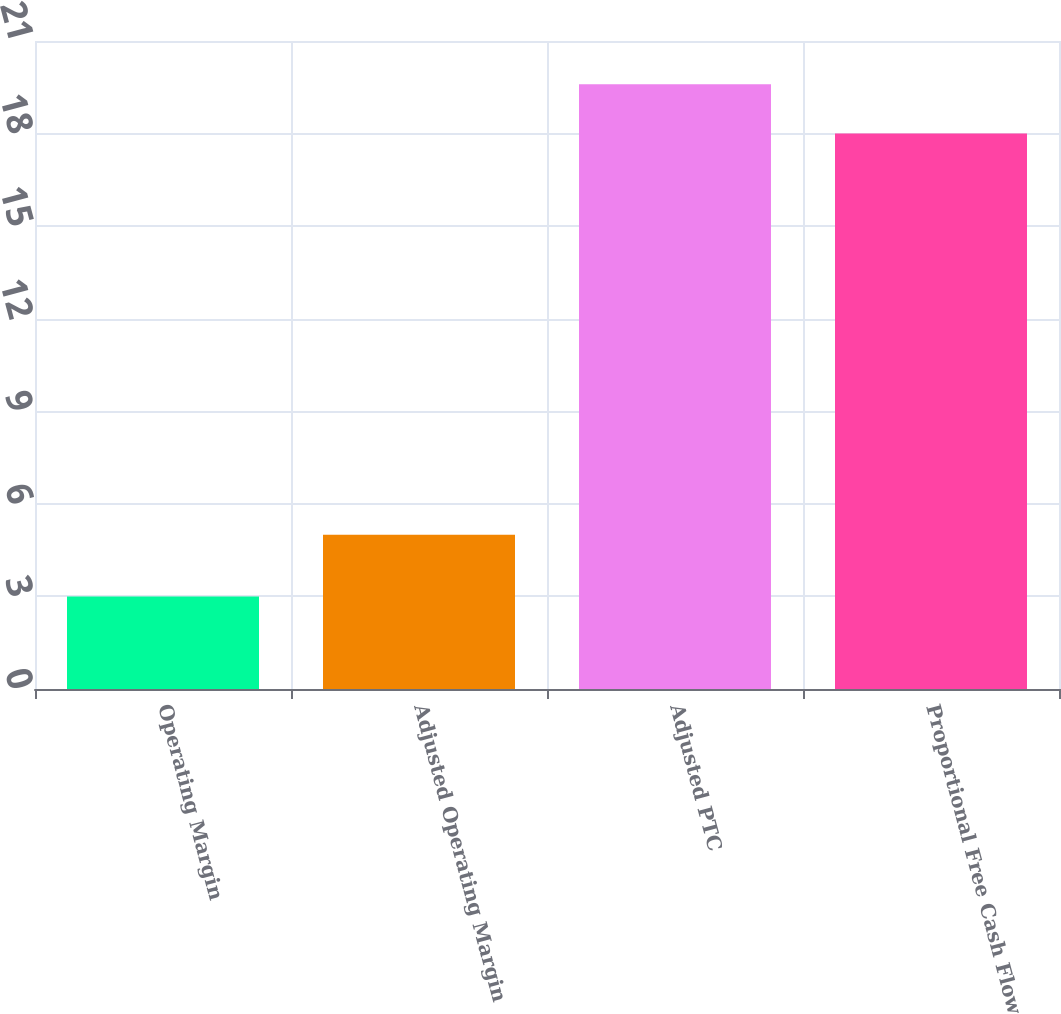Convert chart to OTSL. <chart><loc_0><loc_0><loc_500><loc_500><bar_chart><fcel>Operating Margin<fcel>Adjusted Operating Margin<fcel>Adjusted PTC<fcel>Proportional Free Cash Flow<nl><fcel>3<fcel>5<fcel>19.6<fcel>18<nl></chart> 